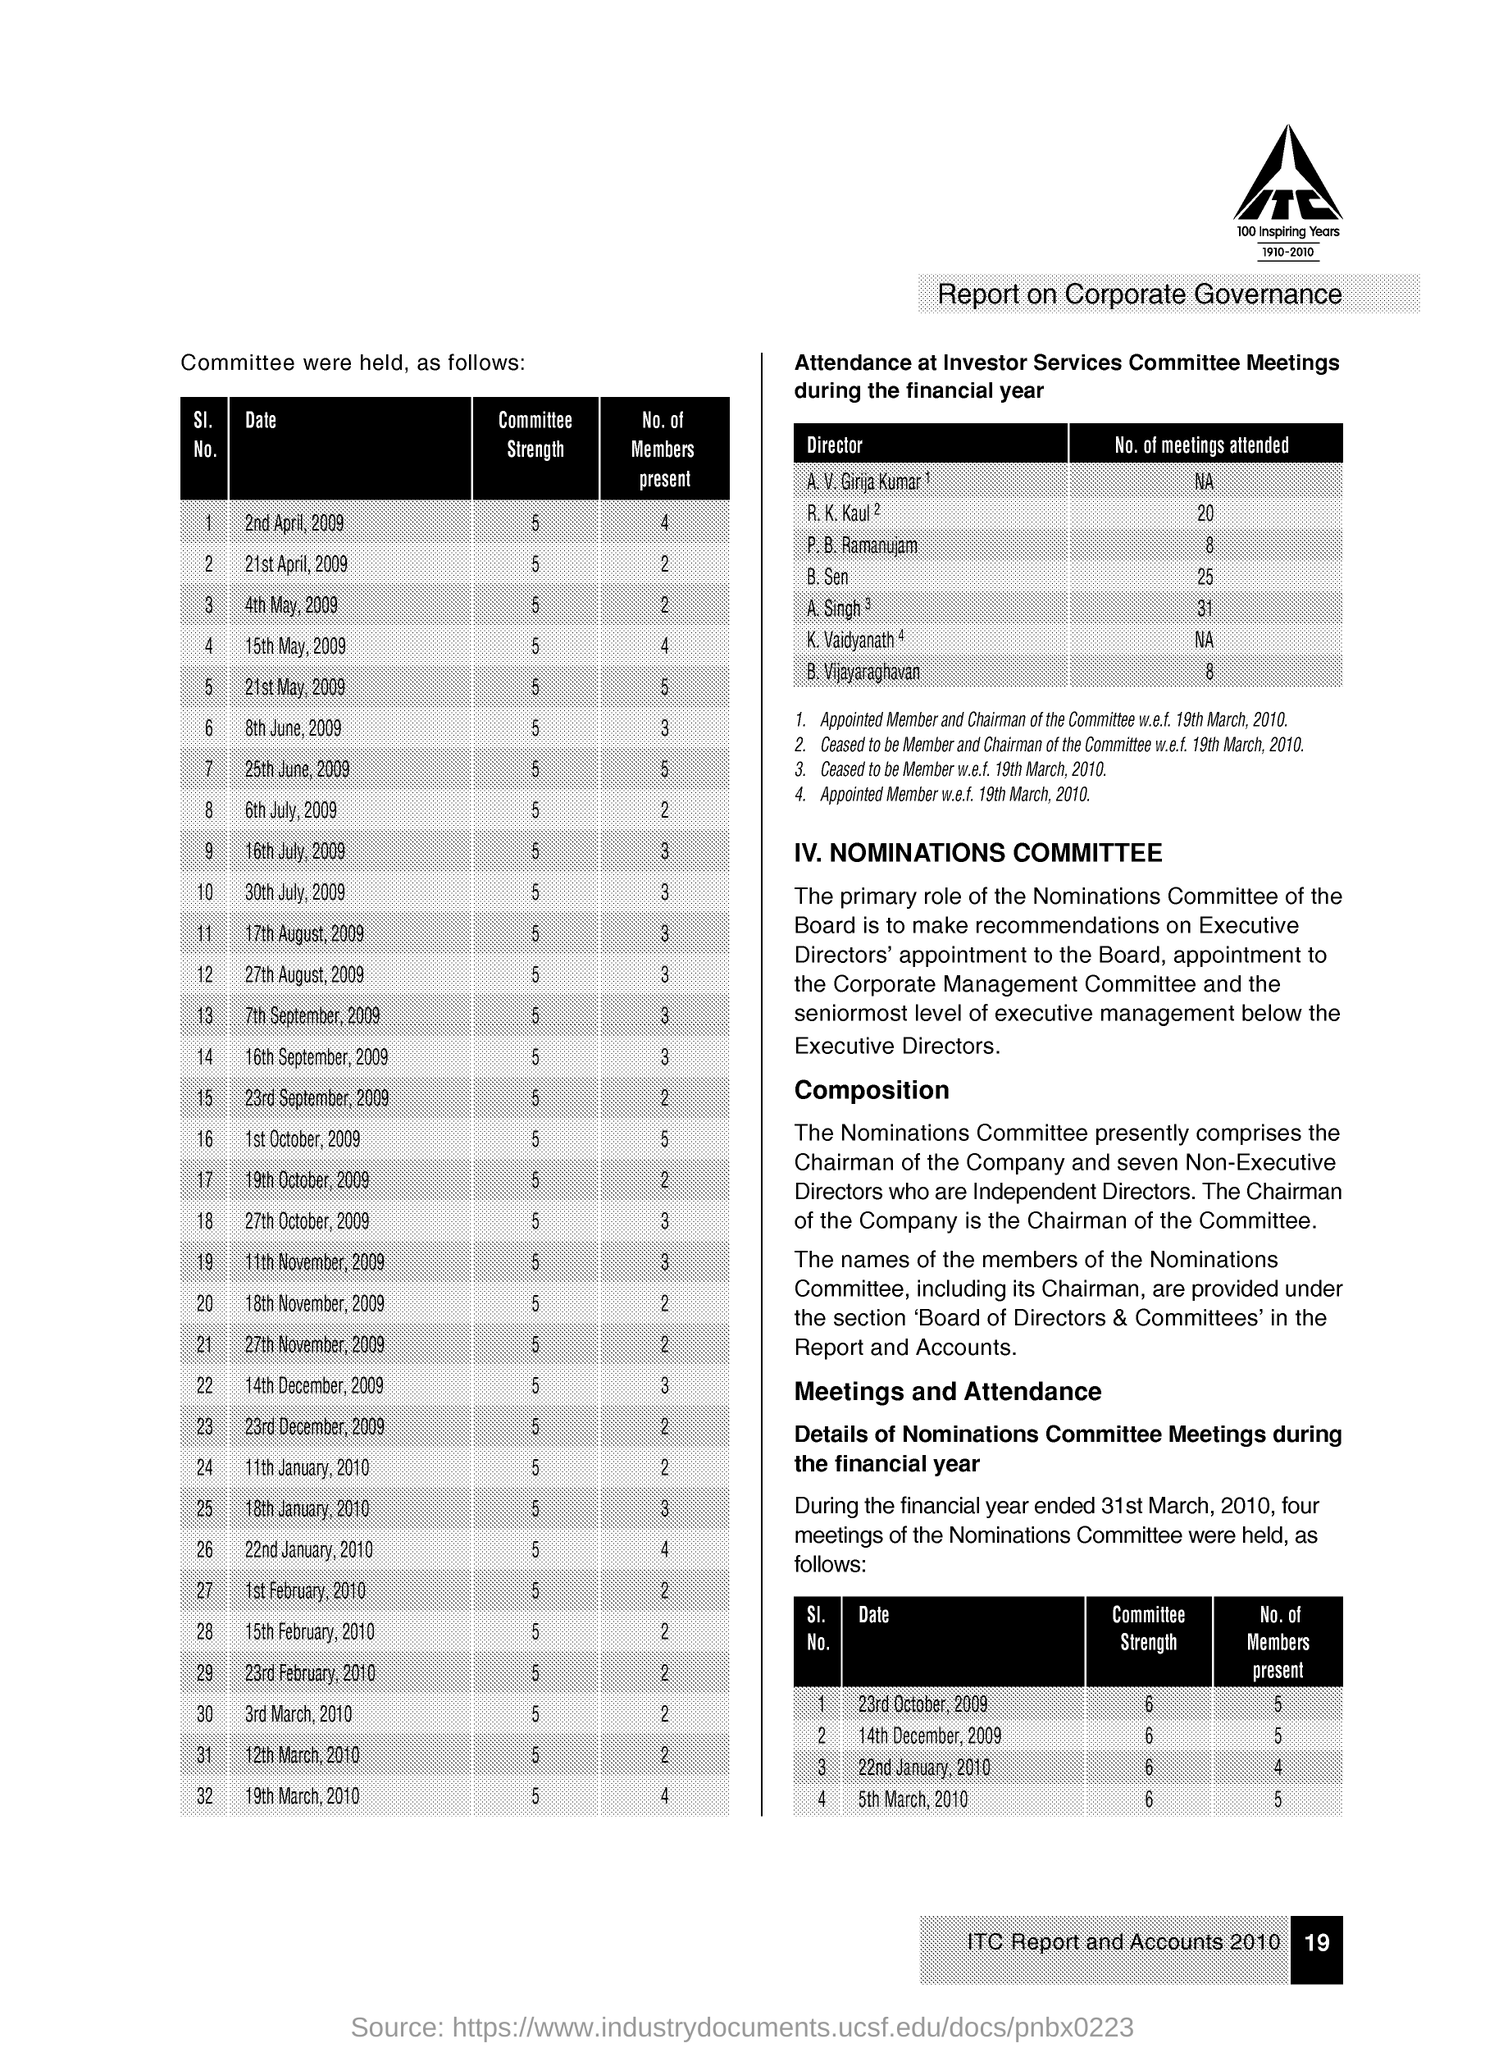List a handful of essential elements in this visual. The committee strength on April 2nd, 2009 was 5. B Vijayaraghavan attended 8 meetings. As of July 30th, 2009, there were present 3 members. 